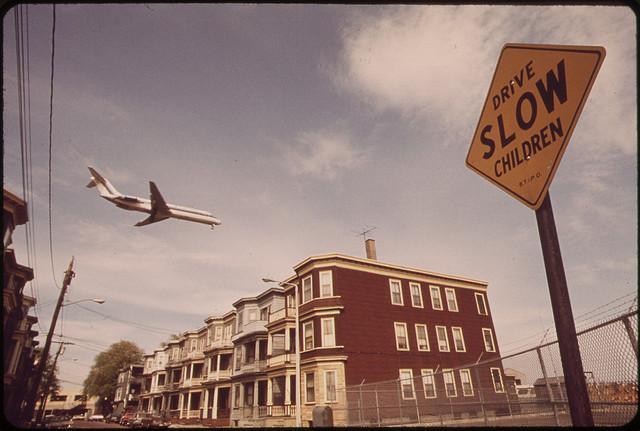How many signs are in this picture?
Give a very brief answer. 1. How many people are riding a bike?
Give a very brief answer. 0. 